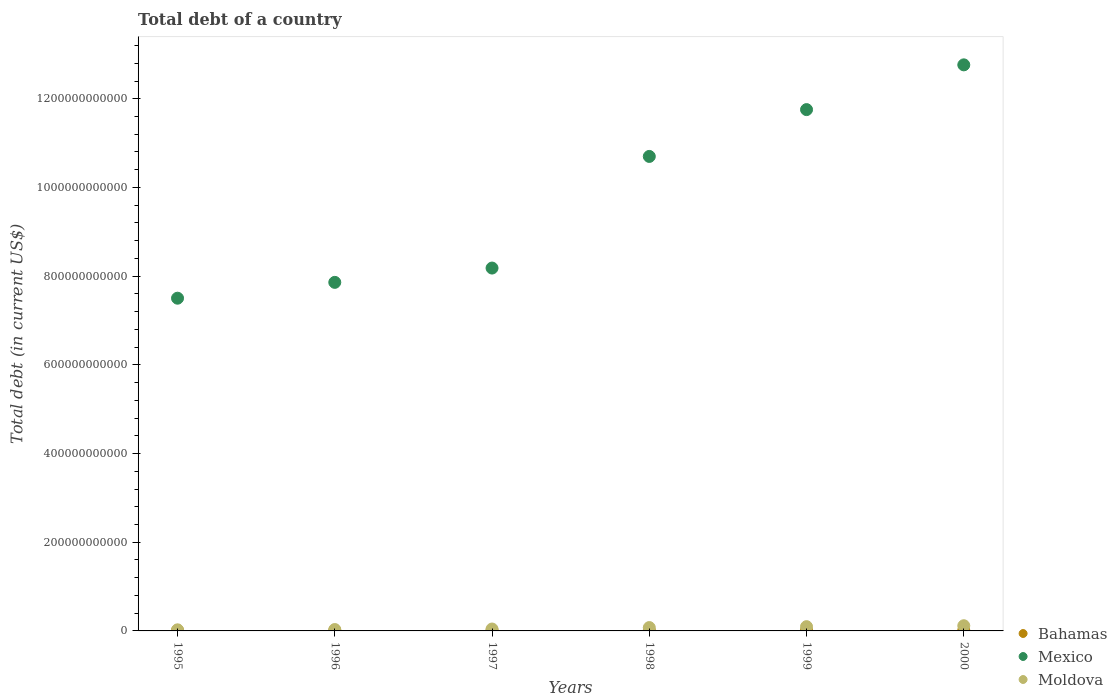What is the debt in Mexico in 1995?
Offer a very short reply. 7.50e+11. Across all years, what is the maximum debt in Mexico?
Give a very brief answer. 1.28e+12. Across all years, what is the minimum debt in Mexico?
Offer a very short reply. 7.50e+11. In which year was the debt in Moldova maximum?
Give a very brief answer. 2000. What is the total debt in Mexico in the graph?
Make the answer very short. 5.88e+12. What is the difference between the debt in Moldova in 1997 and that in 1999?
Ensure brevity in your answer.  -5.31e+09. What is the difference between the debt in Moldova in 1998 and the debt in Bahamas in 2000?
Provide a short and direct response. 6.04e+09. What is the average debt in Moldova per year?
Provide a succinct answer. 6.45e+09. In the year 1995, what is the difference between the debt in Bahamas and debt in Moldova?
Keep it short and to the point. -1.27e+09. In how many years, is the debt in Mexico greater than 160000000000 US$?
Make the answer very short. 6. What is the ratio of the debt in Moldova in 1999 to that in 2000?
Ensure brevity in your answer.  0.82. What is the difference between the highest and the second highest debt in Mexico?
Your answer should be very brief. 1.01e+11. What is the difference between the highest and the lowest debt in Moldova?
Offer a very short reply. 9.26e+09. Does the debt in Bahamas monotonically increase over the years?
Your answer should be very brief. Yes. Is the debt in Mexico strictly greater than the debt in Moldova over the years?
Your answer should be compact. Yes. How many dotlines are there?
Your answer should be compact. 3. How many years are there in the graph?
Make the answer very short. 6. What is the difference between two consecutive major ticks on the Y-axis?
Offer a terse response. 2.00e+11. Are the values on the major ticks of Y-axis written in scientific E-notation?
Your answer should be very brief. No. Does the graph contain any zero values?
Your answer should be compact. No. Does the graph contain grids?
Offer a very short reply. No. How many legend labels are there?
Offer a terse response. 3. What is the title of the graph?
Provide a succinct answer. Total debt of a country. Does "Uganda" appear as one of the legend labels in the graph?
Ensure brevity in your answer.  No. What is the label or title of the X-axis?
Keep it short and to the point. Years. What is the label or title of the Y-axis?
Provide a short and direct response. Total debt (in current US$). What is the Total debt (in current US$) in Bahamas in 1995?
Your response must be concise. 1.17e+09. What is the Total debt (in current US$) of Mexico in 1995?
Make the answer very short. 7.50e+11. What is the Total debt (in current US$) of Moldova in 1995?
Keep it short and to the point. 2.44e+09. What is the Total debt (in current US$) in Bahamas in 1996?
Make the answer very short. 1.24e+09. What is the Total debt (in current US$) of Mexico in 1996?
Your response must be concise. 7.86e+11. What is the Total debt (in current US$) of Moldova in 1996?
Keep it short and to the point. 3.13e+09. What is the Total debt (in current US$) of Bahamas in 1997?
Provide a short and direct response. 1.38e+09. What is the Total debt (in current US$) in Mexico in 1997?
Your response must be concise. 8.18e+11. What is the Total debt (in current US$) in Moldova in 1997?
Your response must be concise. 4.29e+09. What is the Total debt (in current US$) in Bahamas in 1998?
Provide a succinct answer. 1.43e+09. What is the Total debt (in current US$) of Mexico in 1998?
Offer a very short reply. 1.07e+12. What is the Total debt (in current US$) in Moldova in 1998?
Offer a terse response. 7.56e+09. What is the Total debt (in current US$) of Bahamas in 1999?
Keep it short and to the point. 1.51e+09. What is the Total debt (in current US$) of Mexico in 1999?
Give a very brief answer. 1.18e+12. What is the Total debt (in current US$) in Moldova in 1999?
Provide a succinct answer. 9.60e+09. What is the Total debt (in current US$) of Bahamas in 2000?
Your answer should be compact. 1.51e+09. What is the Total debt (in current US$) in Mexico in 2000?
Your response must be concise. 1.28e+12. What is the Total debt (in current US$) in Moldova in 2000?
Keep it short and to the point. 1.17e+1. Across all years, what is the maximum Total debt (in current US$) in Bahamas?
Give a very brief answer. 1.51e+09. Across all years, what is the maximum Total debt (in current US$) in Mexico?
Keep it short and to the point. 1.28e+12. Across all years, what is the maximum Total debt (in current US$) of Moldova?
Provide a short and direct response. 1.17e+1. Across all years, what is the minimum Total debt (in current US$) of Bahamas?
Provide a succinct answer. 1.17e+09. Across all years, what is the minimum Total debt (in current US$) in Mexico?
Offer a terse response. 7.50e+11. Across all years, what is the minimum Total debt (in current US$) in Moldova?
Make the answer very short. 2.44e+09. What is the total Total debt (in current US$) in Bahamas in the graph?
Your response must be concise. 8.23e+09. What is the total Total debt (in current US$) of Mexico in the graph?
Offer a terse response. 5.88e+12. What is the total Total debt (in current US$) in Moldova in the graph?
Your answer should be very brief. 3.87e+1. What is the difference between the Total debt (in current US$) in Bahamas in 1995 and that in 1996?
Offer a terse response. -6.93e+07. What is the difference between the Total debt (in current US$) in Mexico in 1995 and that in 1996?
Provide a short and direct response. -3.57e+1. What is the difference between the Total debt (in current US$) in Moldova in 1995 and that in 1996?
Give a very brief answer. -6.90e+08. What is the difference between the Total debt (in current US$) of Bahamas in 1995 and that in 1997?
Ensure brevity in your answer.  -2.10e+08. What is the difference between the Total debt (in current US$) in Mexico in 1995 and that in 1997?
Ensure brevity in your answer.  -6.80e+1. What is the difference between the Total debt (in current US$) of Moldova in 1995 and that in 1997?
Your response must be concise. -1.85e+09. What is the difference between the Total debt (in current US$) of Bahamas in 1995 and that in 1998?
Make the answer very short. -2.66e+08. What is the difference between the Total debt (in current US$) in Mexico in 1995 and that in 1998?
Make the answer very short. -3.20e+11. What is the difference between the Total debt (in current US$) of Moldova in 1995 and that in 1998?
Provide a short and direct response. -5.12e+09. What is the difference between the Total debt (in current US$) of Bahamas in 1995 and that in 1999?
Keep it short and to the point. -3.43e+08. What is the difference between the Total debt (in current US$) in Mexico in 1995 and that in 1999?
Your answer should be very brief. -4.25e+11. What is the difference between the Total debt (in current US$) of Moldova in 1995 and that in 1999?
Make the answer very short. -7.16e+09. What is the difference between the Total debt (in current US$) in Bahamas in 1995 and that in 2000?
Offer a terse response. -3.49e+08. What is the difference between the Total debt (in current US$) of Mexico in 1995 and that in 2000?
Your answer should be compact. -5.26e+11. What is the difference between the Total debt (in current US$) in Moldova in 1995 and that in 2000?
Your answer should be very brief. -9.26e+09. What is the difference between the Total debt (in current US$) of Bahamas in 1996 and that in 1997?
Provide a short and direct response. -1.41e+08. What is the difference between the Total debt (in current US$) of Mexico in 1996 and that in 1997?
Offer a terse response. -3.22e+1. What is the difference between the Total debt (in current US$) of Moldova in 1996 and that in 1997?
Provide a succinct answer. -1.16e+09. What is the difference between the Total debt (in current US$) of Bahamas in 1996 and that in 1998?
Your answer should be compact. -1.97e+08. What is the difference between the Total debt (in current US$) in Mexico in 1996 and that in 1998?
Make the answer very short. -2.84e+11. What is the difference between the Total debt (in current US$) of Moldova in 1996 and that in 1998?
Provide a succinct answer. -4.43e+09. What is the difference between the Total debt (in current US$) of Bahamas in 1996 and that in 1999?
Your answer should be compact. -2.74e+08. What is the difference between the Total debt (in current US$) in Mexico in 1996 and that in 1999?
Your answer should be very brief. -3.90e+11. What is the difference between the Total debt (in current US$) in Moldova in 1996 and that in 1999?
Offer a very short reply. -6.47e+09. What is the difference between the Total debt (in current US$) in Bahamas in 1996 and that in 2000?
Your response must be concise. -2.79e+08. What is the difference between the Total debt (in current US$) in Mexico in 1996 and that in 2000?
Your answer should be compact. -4.90e+11. What is the difference between the Total debt (in current US$) in Moldova in 1996 and that in 2000?
Offer a very short reply. -8.57e+09. What is the difference between the Total debt (in current US$) in Bahamas in 1997 and that in 1998?
Your answer should be very brief. -5.60e+07. What is the difference between the Total debt (in current US$) in Mexico in 1997 and that in 1998?
Offer a very short reply. -2.52e+11. What is the difference between the Total debt (in current US$) of Moldova in 1997 and that in 1998?
Provide a succinct answer. -3.27e+09. What is the difference between the Total debt (in current US$) in Bahamas in 1997 and that in 1999?
Ensure brevity in your answer.  -1.34e+08. What is the difference between the Total debt (in current US$) of Mexico in 1997 and that in 1999?
Your answer should be very brief. -3.57e+11. What is the difference between the Total debt (in current US$) of Moldova in 1997 and that in 1999?
Your answer should be very brief. -5.31e+09. What is the difference between the Total debt (in current US$) in Bahamas in 1997 and that in 2000?
Offer a terse response. -1.39e+08. What is the difference between the Total debt (in current US$) in Mexico in 1997 and that in 2000?
Your answer should be compact. -4.58e+11. What is the difference between the Total debt (in current US$) of Moldova in 1997 and that in 2000?
Keep it short and to the point. -7.41e+09. What is the difference between the Total debt (in current US$) in Bahamas in 1998 and that in 1999?
Offer a terse response. -7.75e+07. What is the difference between the Total debt (in current US$) in Mexico in 1998 and that in 1999?
Give a very brief answer. -1.06e+11. What is the difference between the Total debt (in current US$) in Moldova in 1998 and that in 1999?
Your answer should be very brief. -2.04e+09. What is the difference between the Total debt (in current US$) in Bahamas in 1998 and that in 2000?
Keep it short and to the point. -8.28e+07. What is the difference between the Total debt (in current US$) of Mexico in 1998 and that in 2000?
Provide a short and direct response. -2.07e+11. What is the difference between the Total debt (in current US$) in Moldova in 1998 and that in 2000?
Provide a succinct answer. -4.14e+09. What is the difference between the Total debt (in current US$) of Bahamas in 1999 and that in 2000?
Provide a short and direct response. -5.30e+06. What is the difference between the Total debt (in current US$) in Mexico in 1999 and that in 2000?
Offer a very short reply. -1.01e+11. What is the difference between the Total debt (in current US$) of Moldova in 1999 and that in 2000?
Ensure brevity in your answer.  -2.10e+09. What is the difference between the Total debt (in current US$) of Bahamas in 1995 and the Total debt (in current US$) of Mexico in 1996?
Make the answer very short. -7.85e+11. What is the difference between the Total debt (in current US$) in Bahamas in 1995 and the Total debt (in current US$) in Moldova in 1996?
Your answer should be compact. -1.96e+09. What is the difference between the Total debt (in current US$) in Mexico in 1995 and the Total debt (in current US$) in Moldova in 1996?
Offer a very short reply. 7.47e+11. What is the difference between the Total debt (in current US$) of Bahamas in 1995 and the Total debt (in current US$) of Mexico in 1997?
Offer a terse response. -8.17e+11. What is the difference between the Total debt (in current US$) of Bahamas in 1995 and the Total debt (in current US$) of Moldova in 1997?
Make the answer very short. -3.12e+09. What is the difference between the Total debt (in current US$) of Mexico in 1995 and the Total debt (in current US$) of Moldova in 1997?
Your answer should be very brief. 7.46e+11. What is the difference between the Total debt (in current US$) of Bahamas in 1995 and the Total debt (in current US$) of Mexico in 1998?
Your answer should be very brief. -1.07e+12. What is the difference between the Total debt (in current US$) of Bahamas in 1995 and the Total debt (in current US$) of Moldova in 1998?
Provide a succinct answer. -6.39e+09. What is the difference between the Total debt (in current US$) of Mexico in 1995 and the Total debt (in current US$) of Moldova in 1998?
Your answer should be very brief. 7.43e+11. What is the difference between the Total debt (in current US$) of Bahamas in 1995 and the Total debt (in current US$) of Mexico in 1999?
Your response must be concise. -1.17e+12. What is the difference between the Total debt (in current US$) in Bahamas in 1995 and the Total debt (in current US$) in Moldova in 1999?
Offer a terse response. -8.43e+09. What is the difference between the Total debt (in current US$) of Mexico in 1995 and the Total debt (in current US$) of Moldova in 1999?
Keep it short and to the point. 7.41e+11. What is the difference between the Total debt (in current US$) of Bahamas in 1995 and the Total debt (in current US$) of Mexico in 2000?
Your answer should be compact. -1.28e+12. What is the difference between the Total debt (in current US$) in Bahamas in 1995 and the Total debt (in current US$) in Moldova in 2000?
Make the answer very short. -1.05e+1. What is the difference between the Total debt (in current US$) of Mexico in 1995 and the Total debt (in current US$) of Moldova in 2000?
Your answer should be very brief. 7.39e+11. What is the difference between the Total debt (in current US$) in Bahamas in 1996 and the Total debt (in current US$) in Mexico in 1997?
Your answer should be very brief. -8.17e+11. What is the difference between the Total debt (in current US$) of Bahamas in 1996 and the Total debt (in current US$) of Moldova in 1997?
Give a very brief answer. -3.05e+09. What is the difference between the Total debt (in current US$) of Mexico in 1996 and the Total debt (in current US$) of Moldova in 1997?
Keep it short and to the point. 7.82e+11. What is the difference between the Total debt (in current US$) in Bahamas in 1996 and the Total debt (in current US$) in Mexico in 1998?
Offer a very short reply. -1.07e+12. What is the difference between the Total debt (in current US$) of Bahamas in 1996 and the Total debt (in current US$) of Moldova in 1998?
Provide a succinct answer. -6.32e+09. What is the difference between the Total debt (in current US$) of Mexico in 1996 and the Total debt (in current US$) of Moldova in 1998?
Your answer should be very brief. 7.78e+11. What is the difference between the Total debt (in current US$) of Bahamas in 1996 and the Total debt (in current US$) of Mexico in 1999?
Ensure brevity in your answer.  -1.17e+12. What is the difference between the Total debt (in current US$) of Bahamas in 1996 and the Total debt (in current US$) of Moldova in 1999?
Give a very brief answer. -8.36e+09. What is the difference between the Total debt (in current US$) in Mexico in 1996 and the Total debt (in current US$) in Moldova in 1999?
Give a very brief answer. 7.76e+11. What is the difference between the Total debt (in current US$) of Bahamas in 1996 and the Total debt (in current US$) of Mexico in 2000?
Your answer should be very brief. -1.28e+12. What is the difference between the Total debt (in current US$) in Bahamas in 1996 and the Total debt (in current US$) in Moldova in 2000?
Offer a very short reply. -1.05e+1. What is the difference between the Total debt (in current US$) of Mexico in 1996 and the Total debt (in current US$) of Moldova in 2000?
Keep it short and to the point. 7.74e+11. What is the difference between the Total debt (in current US$) in Bahamas in 1997 and the Total debt (in current US$) in Mexico in 1998?
Your answer should be very brief. -1.07e+12. What is the difference between the Total debt (in current US$) of Bahamas in 1997 and the Total debt (in current US$) of Moldova in 1998?
Keep it short and to the point. -6.18e+09. What is the difference between the Total debt (in current US$) in Mexico in 1997 and the Total debt (in current US$) in Moldova in 1998?
Your response must be concise. 8.11e+11. What is the difference between the Total debt (in current US$) of Bahamas in 1997 and the Total debt (in current US$) of Mexico in 1999?
Provide a short and direct response. -1.17e+12. What is the difference between the Total debt (in current US$) of Bahamas in 1997 and the Total debt (in current US$) of Moldova in 1999?
Ensure brevity in your answer.  -8.22e+09. What is the difference between the Total debt (in current US$) in Mexico in 1997 and the Total debt (in current US$) in Moldova in 1999?
Keep it short and to the point. 8.09e+11. What is the difference between the Total debt (in current US$) of Bahamas in 1997 and the Total debt (in current US$) of Mexico in 2000?
Offer a terse response. -1.28e+12. What is the difference between the Total debt (in current US$) of Bahamas in 1997 and the Total debt (in current US$) of Moldova in 2000?
Provide a short and direct response. -1.03e+1. What is the difference between the Total debt (in current US$) of Mexico in 1997 and the Total debt (in current US$) of Moldova in 2000?
Provide a short and direct response. 8.07e+11. What is the difference between the Total debt (in current US$) of Bahamas in 1998 and the Total debt (in current US$) of Mexico in 1999?
Make the answer very short. -1.17e+12. What is the difference between the Total debt (in current US$) in Bahamas in 1998 and the Total debt (in current US$) in Moldova in 1999?
Your answer should be compact. -8.17e+09. What is the difference between the Total debt (in current US$) in Mexico in 1998 and the Total debt (in current US$) in Moldova in 1999?
Offer a terse response. 1.06e+12. What is the difference between the Total debt (in current US$) in Bahamas in 1998 and the Total debt (in current US$) in Mexico in 2000?
Your answer should be compact. -1.28e+12. What is the difference between the Total debt (in current US$) of Bahamas in 1998 and the Total debt (in current US$) of Moldova in 2000?
Give a very brief answer. -1.03e+1. What is the difference between the Total debt (in current US$) of Mexico in 1998 and the Total debt (in current US$) of Moldova in 2000?
Keep it short and to the point. 1.06e+12. What is the difference between the Total debt (in current US$) in Bahamas in 1999 and the Total debt (in current US$) in Mexico in 2000?
Provide a short and direct response. -1.27e+12. What is the difference between the Total debt (in current US$) in Bahamas in 1999 and the Total debt (in current US$) in Moldova in 2000?
Your answer should be compact. -1.02e+1. What is the difference between the Total debt (in current US$) of Mexico in 1999 and the Total debt (in current US$) of Moldova in 2000?
Provide a short and direct response. 1.16e+12. What is the average Total debt (in current US$) of Bahamas per year?
Give a very brief answer. 1.37e+09. What is the average Total debt (in current US$) of Mexico per year?
Give a very brief answer. 9.79e+11. What is the average Total debt (in current US$) in Moldova per year?
Provide a succinct answer. 6.45e+09. In the year 1995, what is the difference between the Total debt (in current US$) of Bahamas and Total debt (in current US$) of Mexico?
Your response must be concise. -7.49e+11. In the year 1995, what is the difference between the Total debt (in current US$) of Bahamas and Total debt (in current US$) of Moldova?
Provide a short and direct response. -1.27e+09. In the year 1995, what is the difference between the Total debt (in current US$) of Mexico and Total debt (in current US$) of Moldova?
Your answer should be very brief. 7.48e+11. In the year 1996, what is the difference between the Total debt (in current US$) in Bahamas and Total debt (in current US$) in Mexico?
Your response must be concise. -7.85e+11. In the year 1996, what is the difference between the Total debt (in current US$) of Bahamas and Total debt (in current US$) of Moldova?
Give a very brief answer. -1.89e+09. In the year 1996, what is the difference between the Total debt (in current US$) in Mexico and Total debt (in current US$) in Moldova?
Keep it short and to the point. 7.83e+11. In the year 1997, what is the difference between the Total debt (in current US$) in Bahamas and Total debt (in current US$) in Mexico?
Ensure brevity in your answer.  -8.17e+11. In the year 1997, what is the difference between the Total debt (in current US$) of Bahamas and Total debt (in current US$) of Moldova?
Make the answer very short. -2.91e+09. In the year 1997, what is the difference between the Total debt (in current US$) in Mexico and Total debt (in current US$) in Moldova?
Your response must be concise. 8.14e+11. In the year 1998, what is the difference between the Total debt (in current US$) in Bahamas and Total debt (in current US$) in Mexico?
Provide a succinct answer. -1.07e+12. In the year 1998, what is the difference between the Total debt (in current US$) in Bahamas and Total debt (in current US$) in Moldova?
Keep it short and to the point. -6.12e+09. In the year 1998, what is the difference between the Total debt (in current US$) of Mexico and Total debt (in current US$) of Moldova?
Keep it short and to the point. 1.06e+12. In the year 1999, what is the difference between the Total debt (in current US$) in Bahamas and Total debt (in current US$) in Mexico?
Your answer should be compact. -1.17e+12. In the year 1999, what is the difference between the Total debt (in current US$) in Bahamas and Total debt (in current US$) in Moldova?
Your answer should be compact. -8.09e+09. In the year 1999, what is the difference between the Total debt (in current US$) of Mexico and Total debt (in current US$) of Moldova?
Give a very brief answer. 1.17e+12. In the year 2000, what is the difference between the Total debt (in current US$) of Bahamas and Total debt (in current US$) of Mexico?
Provide a succinct answer. -1.27e+12. In the year 2000, what is the difference between the Total debt (in current US$) of Bahamas and Total debt (in current US$) of Moldova?
Provide a succinct answer. -1.02e+1. In the year 2000, what is the difference between the Total debt (in current US$) in Mexico and Total debt (in current US$) in Moldova?
Your response must be concise. 1.26e+12. What is the ratio of the Total debt (in current US$) of Bahamas in 1995 to that in 1996?
Give a very brief answer. 0.94. What is the ratio of the Total debt (in current US$) in Mexico in 1995 to that in 1996?
Ensure brevity in your answer.  0.95. What is the ratio of the Total debt (in current US$) of Moldova in 1995 to that in 1996?
Keep it short and to the point. 0.78. What is the ratio of the Total debt (in current US$) of Bahamas in 1995 to that in 1997?
Provide a short and direct response. 0.85. What is the ratio of the Total debt (in current US$) of Mexico in 1995 to that in 1997?
Your answer should be very brief. 0.92. What is the ratio of the Total debt (in current US$) in Moldova in 1995 to that in 1997?
Give a very brief answer. 0.57. What is the ratio of the Total debt (in current US$) of Bahamas in 1995 to that in 1998?
Make the answer very short. 0.81. What is the ratio of the Total debt (in current US$) of Mexico in 1995 to that in 1998?
Offer a terse response. 0.7. What is the ratio of the Total debt (in current US$) of Moldova in 1995 to that in 1998?
Your answer should be compact. 0.32. What is the ratio of the Total debt (in current US$) of Bahamas in 1995 to that in 1999?
Your response must be concise. 0.77. What is the ratio of the Total debt (in current US$) in Mexico in 1995 to that in 1999?
Keep it short and to the point. 0.64. What is the ratio of the Total debt (in current US$) of Moldova in 1995 to that in 1999?
Keep it short and to the point. 0.25. What is the ratio of the Total debt (in current US$) of Bahamas in 1995 to that in 2000?
Keep it short and to the point. 0.77. What is the ratio of the Total debt (in current US$) in Mexico in 1995 to that in 2000?
Offer a very short reply. 0.59. What is the ratio of the Total debt (in current US$) of Moldova in 1995 to that in 2000?
Your response must be concise. 0.21. What is the ratio of the Total debt (in current US$) of Bahamas in 1996 to that in 1997?
Provide a succinct answer. 0.9. What is the ratio of the Total debt (in current US$) of Mexico in 1996 to that in 1997?
Provide a short and direct response. 0.96. What is the ratio of the Total debt (in current US$) in Moldova in 1996 to that in 1997?
Give a very brief answer. 0.73. What is the ratio of the Total debt (in current US$) in Bahamas in 1996 to that in 1998?
Your response must be concise. 0.86. What is the ratio of the Total debt (in current US$) in Mexico in 1996 to that in 1998?
Keep it short and to the point. 0.73. What is the ratio of the Total debt (in current US$) of Moldova in 1996 to that in 1998?
Offer a very short reply. 0.41. What is the ratio of the Total debt (in current US$) of Bahamas in 1996 to that in 1999?
Keep it short and to the point. 0.82. What is the ratio of the Total debt (in current US$) of Mexico in 1996 to that in 1999?
Keep it short and to the point. 0.67. What is the ratio of the Total debt (in current US$) in Moldova in 1996 to that in 1999?
Provide a succinct answer. 0.33. What is the ratio of the Total debt (in current US$) of Bahamas in 1996 to that in 2000?
Your answer should be very brief. 0.82. What is the ratio of the Total debt (in current US$) of Mexico in 1996 to that in 2000?
Ensure brevity in your answer.  0.62. What is the ratio of the Total debt (in current US$) in Moldova in 1996 to that in 2000?
Provide a succinct answer. 0.27. What is the ratio of the Total debt (in current US$) in Bahamas in 1997 to that in 1998?
Make the answer very short. 0.96. What is the ratio of the Total debt (in current US$) of Mexico in 1997 to that in 1998?
Your answer should be compact. 0.76. What is the ratio of the Total debt (in current US$) in Moldova in 1997 to that in 1998?
Ensure brevity in your answer.  0.57. What is the ratio of the Total debt (in current US$) of Bahamas in 1997 to that in 1999?
Provide a succinct answer. 0.91. What is the ratio of the Total debt (in current US$) of Mexico in 1997 to that in 1999?
Provide a succinct answer. 0.7. What is the ratio of the Total debt (in current US$) in Moldova in 1997 to that in 1999?
Offer a very short reply. 0.45. What is the ratio of the Total debt (in current US$) of Bahamas in 1997 to that in 2000?
Your answer should be compact. 0.91. What is the ratio of the Total debt (in current US$) in Mexico in 1997 to that in 2000?
Make the answer very short. 0.64. What is the ratio of the Total debt (in current US$) of Moldova in 1997 to that in 2000?
Keep it short and to the point. 0.37. What is the ratio of the Total debt (in current US$) in Bahamas in 1998 to that in 1999?
Keep it short and to the point. 0.95. What is the ratio of the Total debt (in current US$) of Mexico in 1998 to that in 1999?
Your response must be concise. 0.91. What is the ratio of the Total debt (in current US$) in Moldova in 1998 to that in 1999?
Offer a very short reply. 0.79. What is the ratio of the Total debt (in current US$) in Bahamas in 1998 to that in 2000?
Provide a short and direct response. 0.95. What is the ratio of the Total debt (in current US$) of Mexico in 1998 to that in 2000?
Ensure brevity in your answer.  0.84. What is the ratio of the Total debt (in current US$) of Moldova in 1998 to that in 2000?
Keep it short and to the point. 0.65. What is the ratio of the Total debt (in current US$) of Bahamas in 1999 to that in 2000?
Your answer should be very brief. 1. What is the ratio of the Total debt (in current US$) in Mexico in 1999 to that in 2000?
Your response must be concise. 0.92. What is the ratio of the Total debt (in current US$) of Moldova in 1999 to that in 2000?
Give a very brief answer. 0.82. What is the difference between the highest and the second highest Total debt (in current US$) in Bahamas?
Ensure brevity in your answer.  5.30e+06. What is the difference between the highest and the second highest Total debt (in current US$) of Mexico?
Offer a very short reply. 1.01e+11. What is the difference between the highest and the second highest Total debt (in current US$) of Moldova?
Provide a succinct answer. 2.10e+09. What is the difference between the highest and the lowest Total debt (in current US$) in Bahamas?
Your answer should be very brief. 3.49e+08. What is the difference between the highest and the lowest Total debt (in current US$) of Mexico?
Keep it short and to the point. 5.26e+11. What is the difference between the highest and the lowest Total debt (in current US$) of Moldova?
Your answer should be compact. 9.26e+09. 